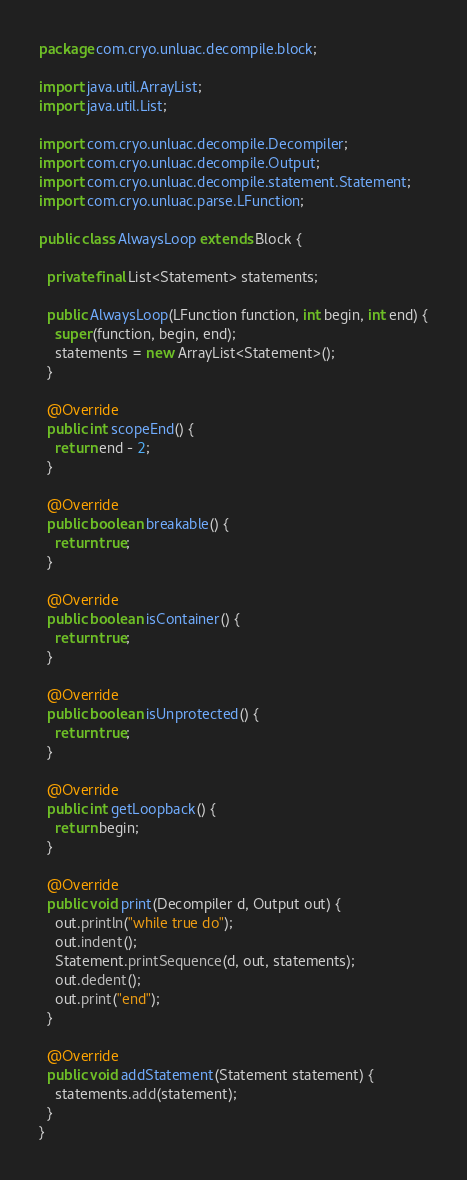<code> <loc_0><loc_0><loc_500><loc_500><_Java_>package com.cryo.unluac.decompile.block;

import java.util.ArrayList;
import java.util.List;

import com.cryo.unluac.decompile.Decompiler;
import com.cryo.unluac.decompile.Output;
import com.cryo.unluac.decompile.statement.Statement;
import com.cryo.unluac.parse.LFunction;

public class AlwaysLoop extends Block {
  
  private final List<Statement> statements;
  
  public AlwaysLoop(LFunction function, int begin, int end) {
    super(function, begin, end);
    statements = new ArrayList<Statement>();
  }
  
  @Override
  public int scopeEnd() {
    return end - 2;
  }
  
  @Override
  public boolean breakable() {
    return true;
  }
  
  @Override
  public boolean isContainer() {
    return true;
  }
  
  @Override
  public boolean isUnprotected() {
    return true;
  }
  
  @Override
  public int getLoopback() {
    return begin;
  }
  
  @Override
  public void print(Decompiler d, Output out) {
    out.println("while true do");
    out.indent();
    Statement.printSequence(d, out, statements);
    out.dedent();
    out.print("end");
  }

  @Override
  public void addStatement(Statement statement) {
    statements.add(statement);
  }
}</code> 